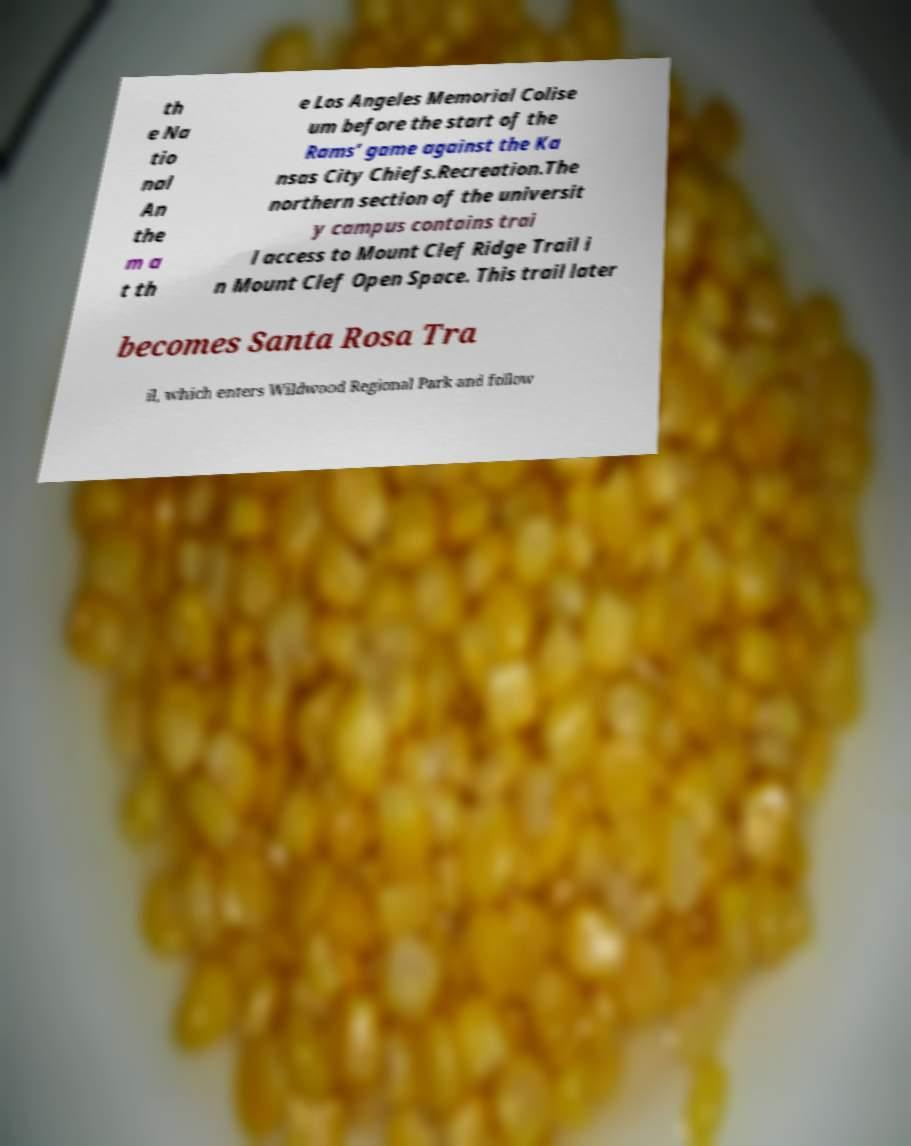Could you extract and type out the text from this image? th e Na tio nal An the m a t th e Los Angeles Memorial Colise um before the start of the Rams’ game against the Ka nsas City Chiefs.Recreation.The northern section of the universit y campus contains trai l access to Mount Clef Ridge Trail i n Mount Clef Open Space. This trail later becomes Santa Rosa Tra il, which enters Wildwood Regional Park and follow 